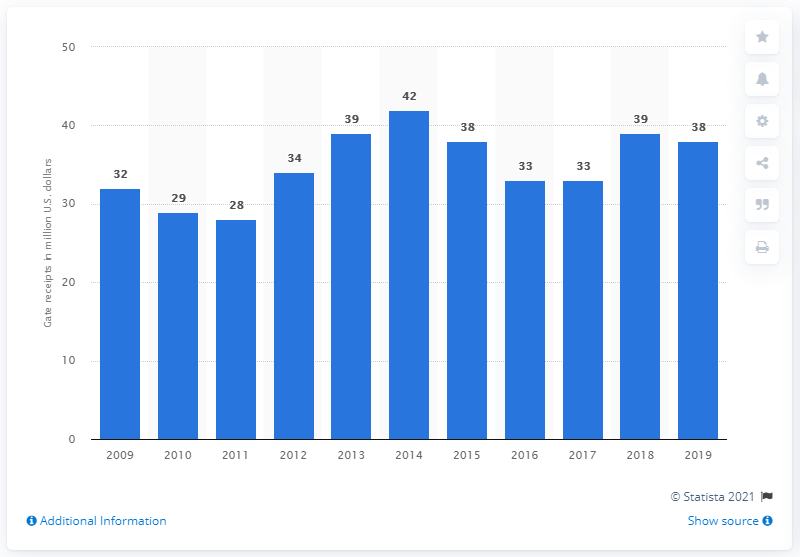Outline some significant characteristics in this image. The gate receipts of the Oakland Athletics in 2019 were 38.. 